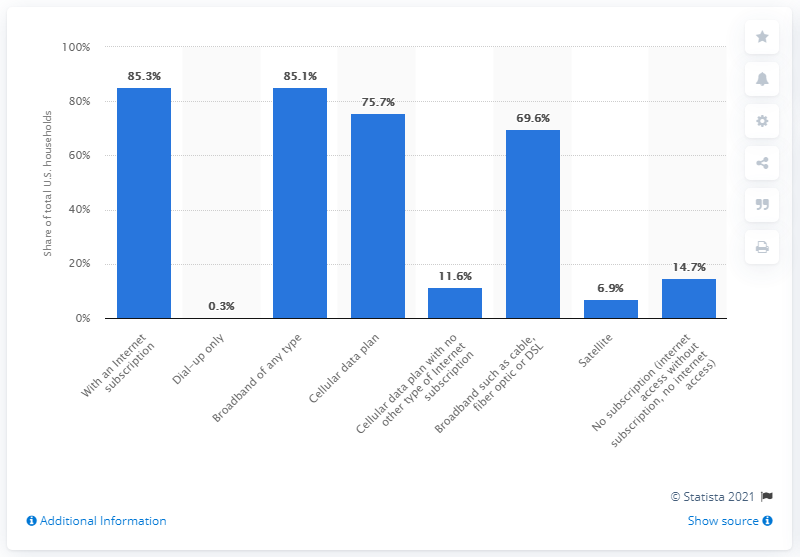Draw attention to some important aspects in this diagram. In 2018, 85.3% of households in the United States had a broadband internet subscription at home. According to a recent survey, 75.7% of households have a cellular data plan, a significant increase from previous years. According to the data, approximately 11.6% of households subscribed to cellular online service as their only form of internet access in the surveyed region. 